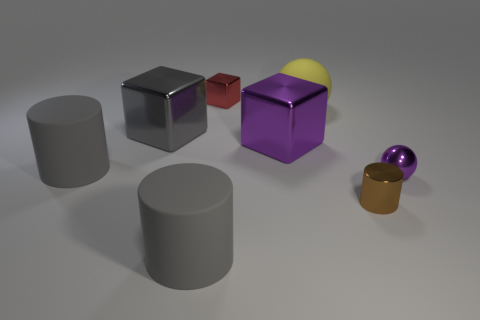Subtract all big gray cylinders. How many cylinders are left? 1 Add 2 gray rubber things. How many objects exist? 10 Subtract 2 blocks. How many blocks are left? 1 Subtract all brown cylinders. How many cylinders are left? 2 Subtract all yellow balls. How many purple blocks are left? 1 Subtract 0 green cubes. How many objects are left? 8 Subtract all cylinders. How many objects are left? 5 Subtract all green spheres. Subtract all yellow cylinders. How many spheres are left? 2 Subtract all gray blocks. Subtract all small metallic balls. How many objects are left? 6 Add 3 big gray matte objects. How many big gray matte objects are left? 5 